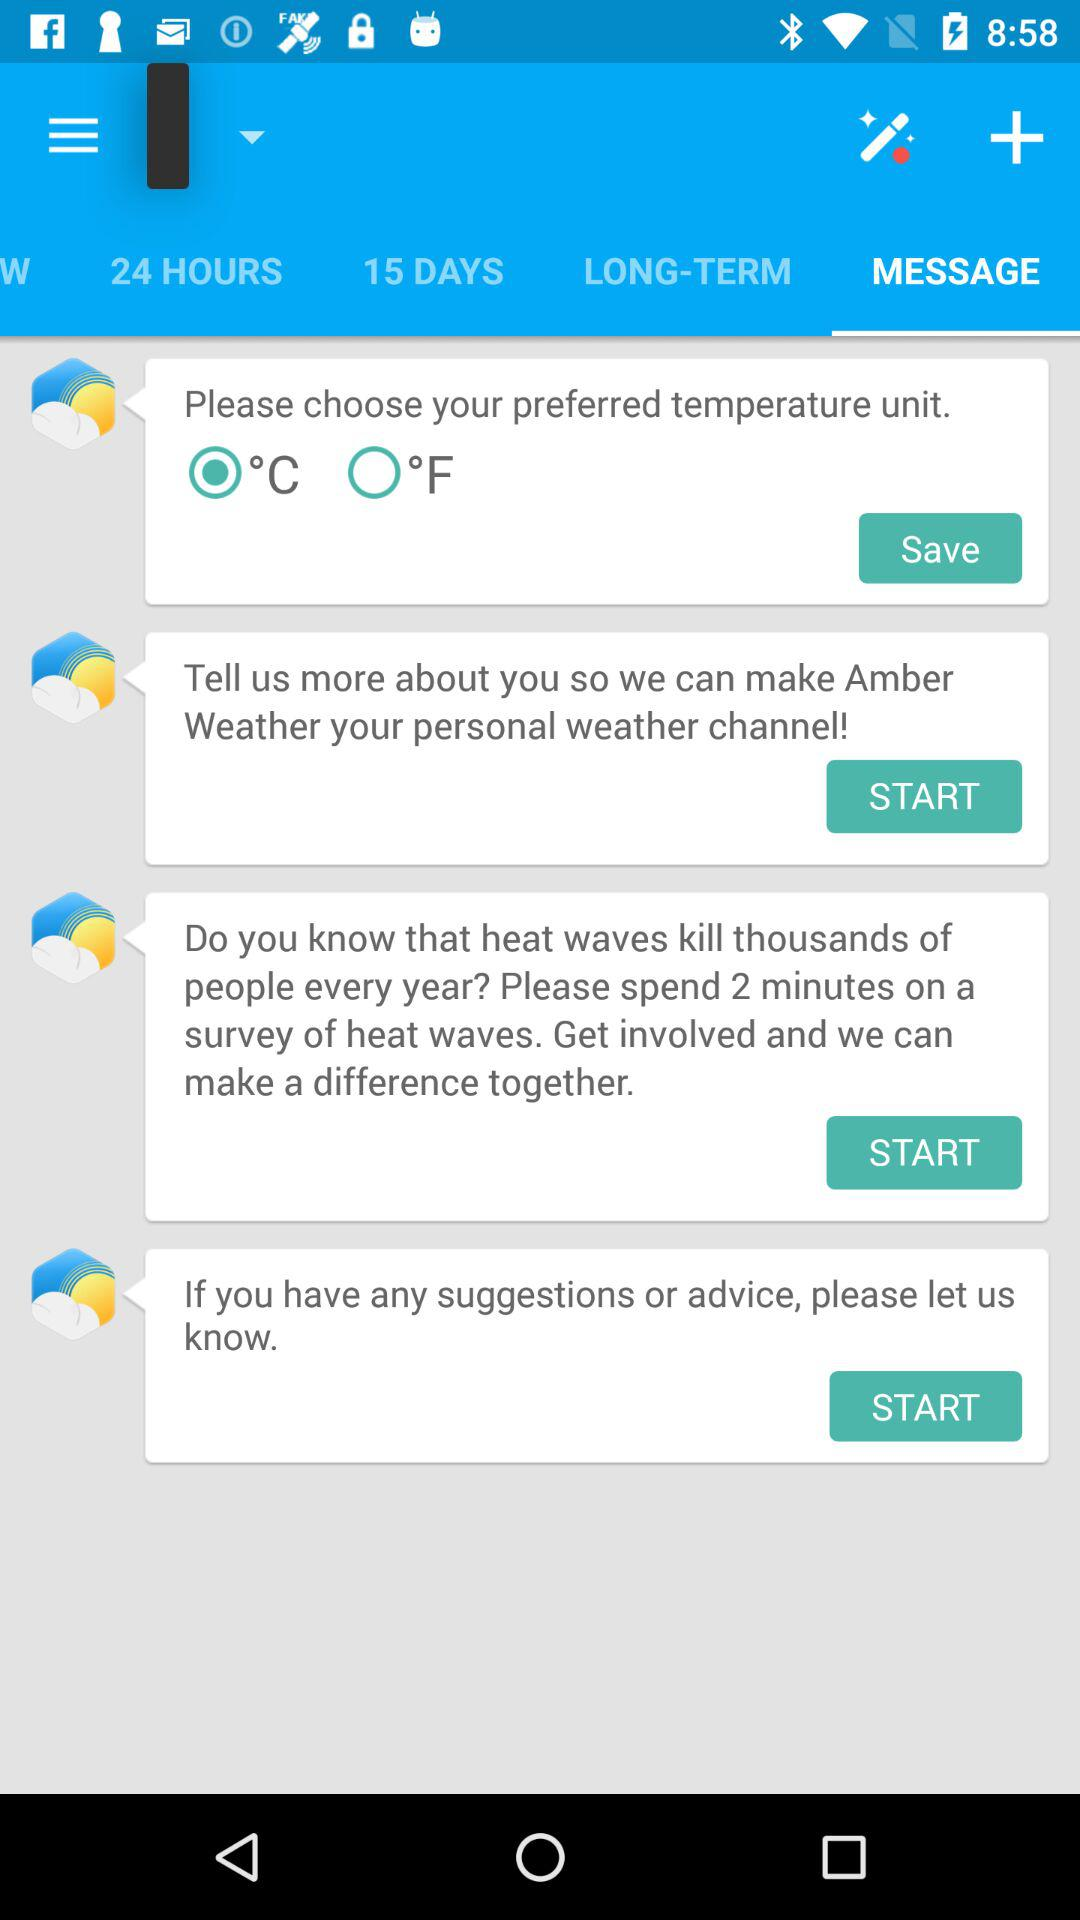Which tab is selected? The selected tab is "MESSAGE". 